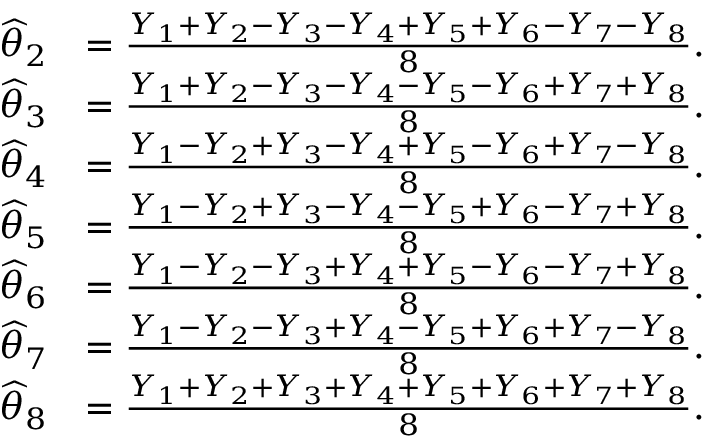Convert formula to latex. <formula><loc_0><loc_0><loc_500><loc_500>{ \begin{array} { r l } { { \widehat { \theta } } _ { 2 } } & { = { \frac { Y _ { 1 } + Y _ { 2 } - Y _ { 3 } - Y _ { 4 } + Y _ { 5 } + Y _ { 6 } - Y _ { 7 } - Y _ { 8 } } { 8 } } . } \\ { { \widehat { \theta } } _ { 3 } } & { = { \frac { Y _ { 1 } + Y _ { 2 } - Y _ { 3 } - Y _ { 4 } - Y _ { 5 } - Y _ { 6 } + Y _ { 7 } + Y _ { 8 } } { 8 } } . } \\ { { \widehat { \theta } } _ { 4 } } & { = { \frac { Y _ { 1 } - Y _ { 2 } + Y _ { 3 } - Y _ { 4 } + Y _ { 5 } - Y _ { 6 } + Y _ { 7 } - Y _ { 8 } } { 8 } } . } \\ { { \widehat { \theta } } _ { 5 } } & { = { \frac { Y _ { 1 } - Y _ { 2 } + Y _ { 3 } - Y _ { 4 } - Y _ { 5 } + Y _ { 6 } - Y _ { 7 } + Y _ { 8 } } { 8 } } . } \\ { { \widehat { \theta } } _ { 6 } } & { = { \frac { Y _ { 1 } - Y _ { 2 } - Y _ { 3 } + Y _ { 4 } + Y _ { 5 } - Y _ { 6 } - Y _ { 7 } + Y _ { 8 } } { 8 } } . } \\ { { \widehat { \theta } } _ { 7 } } & { = { \frac { Y _ { 1 } - Y _ { 2 } - Y _ { 3 } + Y _ { 4 } - Y _ { 5 } + Y _ { 6 } + Y _ { 7 } - Y _ { 8 } } { 8 } } . } \\ { { \widehat { \theta } } _ { 8 } } & { = { \frac { Y _ { 1 } + Y _ { 2 } + Y _ { 3 } + Y _ { 4 } + Y _ { 5 } + Y _ { 6 } + Y _ { 7 } + Y _ { 8 } } { 8 } } . } \end{array} }</formula> 